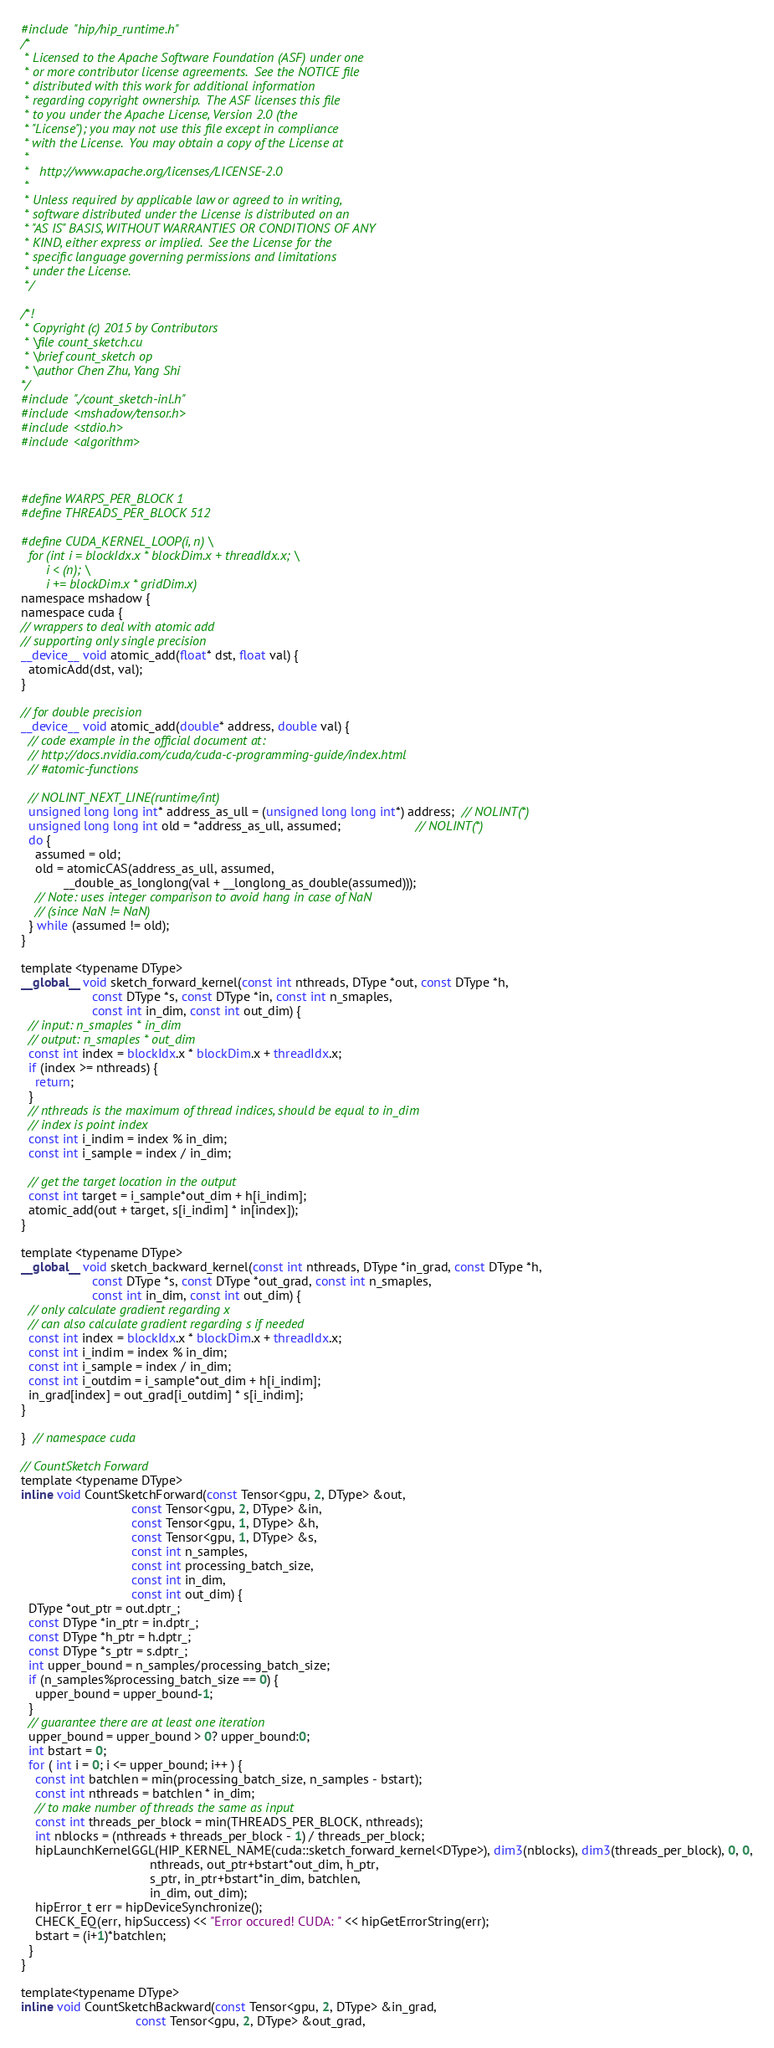Convert code to text. <code><loc_0><loc_0><loc_500><loc_500><_Cuda_>#include "hip/hip_runtime.h"
/*
 * Licensed to the Apache Software Foundation (ASF) under one
 * or more contributor license agreements.  See the NOTICE file
 * distributed with this work for additional information
 * regarding copyright ownership.  The ASF licenses this file
 * to you under the Apache License, Version 2.0 (the
 * "License"); you may not use this file except in compliance
 * with the License.  You may obtain a copy of the License at
 *
 *   http://www.apache.org/licenses/LICENSE-2.0
 *
 * Unless required by applicable law or agreed to in writing,
 * software distributed under the License is distributed on an
 * "AS IS" BASIS, WITHOUT WARRANTIES OR CONDITIONS OF ANY
 * KIND, either express or implied.  See the License for the
 * specific language governing permissions and limitations
 * under the License.
 */

/*!
 * Copyright (c) 2015 by Contributors
 * \file count_sketch.cu
 * \brief count_sketch op
 * \author Chen Zhu, Yang Shi
*/
#include "./count_sketch-inl.h"
#include <mshadow/tensor.h>
#include <stdio.h>
#include <algorithm>



#define WARPS_PER_BLOCK 1
#define THREADS_PER_BLOCK 512

#define CUDA_KERNEL_LOOP(i, n) \
  for (int i = blockIdx.x * blockDim.x + threadIdx.x; \
       i < (n); \
       i += blockDim.x * gridDim.x)
namespace mshadow {
namespace cuda {
// wrappers to deal with atomic add
// supporting only single precision
__device__ void atomic_add(float* dst, float val) {
  atomicAdd(dst, val);
}

// for double precision
__device__ void atomic_add(double* address, double val) {
  // code example in the official document at:
  // http://docs.nvidia.com/cuda/cuda-c-programming-guide/index.html
  // #atomic-functions

  // NOLINT_NEXT_LINE(runtime/int)
  unsigned long long int* address_as_ull = (unsigned long long int*) address;  // NOLINT(*)
  unsigned long long int old = *address_as_ull, assumed;                     // NOLINT(*)
  do {
    assumed = old;
    old = atomicCAS(address_as_ull, assumed,
            __double_as_longlong(val + __longlong_as_double(assumed)));
    // Note: uses integer comparison to avoid hang in case of NaN
    // (since NaN != NaN)
  } while (assumed != old);
}

template <typename DType>
__global__ void sketch_forward_kernel(const int nthreads, DType *out, const DType *h,
                    const DType *s, const DType *in, const int n_smaples,
                    const int in_dim, const int out_dim) {
  // input: n_smaples * in_dim
  // output: n_smaples * out_dim
  const int index = blockIdx.x * blockDim.x + threadIdx.x;
  if (index >= nthreads) {
    return;
  }
  // nthreads is the maximum of thread indices, should be equal to in_dim
  // index is point index
  const int i_indim = index % in_dim;
  const int i_sample = index / in_dim;

  // get the target location in the output
  const int target = i_sample*out_dim + h[i_indim];
  atomic_add(out + target, s[i_indim] * in[index]);
}

template <typename DType>
__global__ void sketch_backward_kernel(const int nthreads, DType *in_grad, const DType *h,
                    const DType *s, const DType *out_grad, const int n_smaples,
                    const int in_dim, const int out_dim) {
  // only calculate gradient regarding x
  // can also calculate gradient regarding s if needed
  const int index = blockIdx.x * blockDim.x + threadIdx.x;
  const int i_indim = index % in_dim;
  const int i_sample = index / in_dim;
  const int i_outdim = i_sample*out_dim + h[i_indim];
  in_grad[index] = out_grad[i_outdim] * s[i_indim];
}

}  // namespace cuda

// CountSketch Forward
template <typename DType>
inline void CountSketchForward(const Tensor<gpu, 2, DType> &out,
                               const Tensor<gpu, 2, DType> &in,
                               const Tensor<gpu, 1, DType> &h,
                               const Tensor<gpu, 1, DType> &s,
                               const int n_samples,
                               const int processing_batch_size,
                               const int in_dim,
                               const int out_dim) {
  DType *out_ptr = out.dptr_;
  const DType *in_ptr = in.dptr_;
  const DType *h_ptr = h.dptr_;
  const DType *s_ptr = s.dptr_;
  int upper_bound = n_samples/processing_batch_size;
  if (n_samples%processing_batch_size == 0) {
    upper_bound = upper_bound-1;
  }
  // guarantee there are at least one iteration
  upper_bound = upper_bound > 0? upper_bound:0;
  int bstart = 0;
  for ( int i = 0; i <= upper_bound; i++ ) {
    const int batchlen = min(processing_batch_size, n_samples - bstart);
    const int nthreads = batchlen * in_dim;
    // to make number of threads the same as input
    const int threads_per_block = min(THREADS_PER_BLOCK, nthreads);
    int nblocks = (nthreads + threads_per_block - 1) / threads_per_block;
    hipLaunchKernelGGL(HIP_KERNEL_NAME(cuda::sketch_forward_kernel<DType>), dim3(nblocks), dim3(threads_per_block), 0, 0,
                                    nthreads, out_ptr+bstart*out_dim, h_ptr,
                                    s_ptr, in_ptr+bstart*in_dim, batchlen,
                                    in_dim, out_dim);
    hipError_t err = hipDeviceSynchronize();
    CHECK_EQ(err, hipSuccess) << "Error occured! CUDA: " << hipGetErrorString(err);
    bstart = (i+1)*batchlen;
  }
}

template<typename DType>
inline void CountSketchBackward(const Tensor<gpu, 2, DType> &in_grad,
                                const Tensor<gpu, 2, DType> &out_grad,</code> 